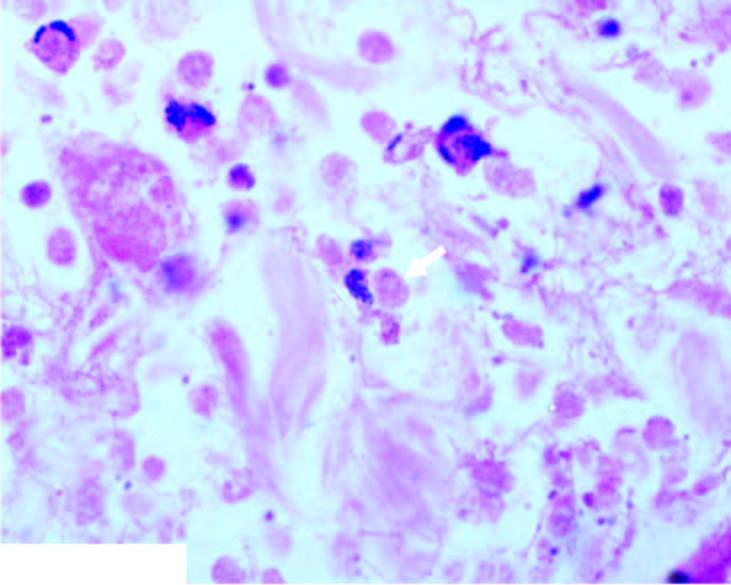where is section from?
Answer the question using a single word or phrase. Margin of amoebic ulcer 